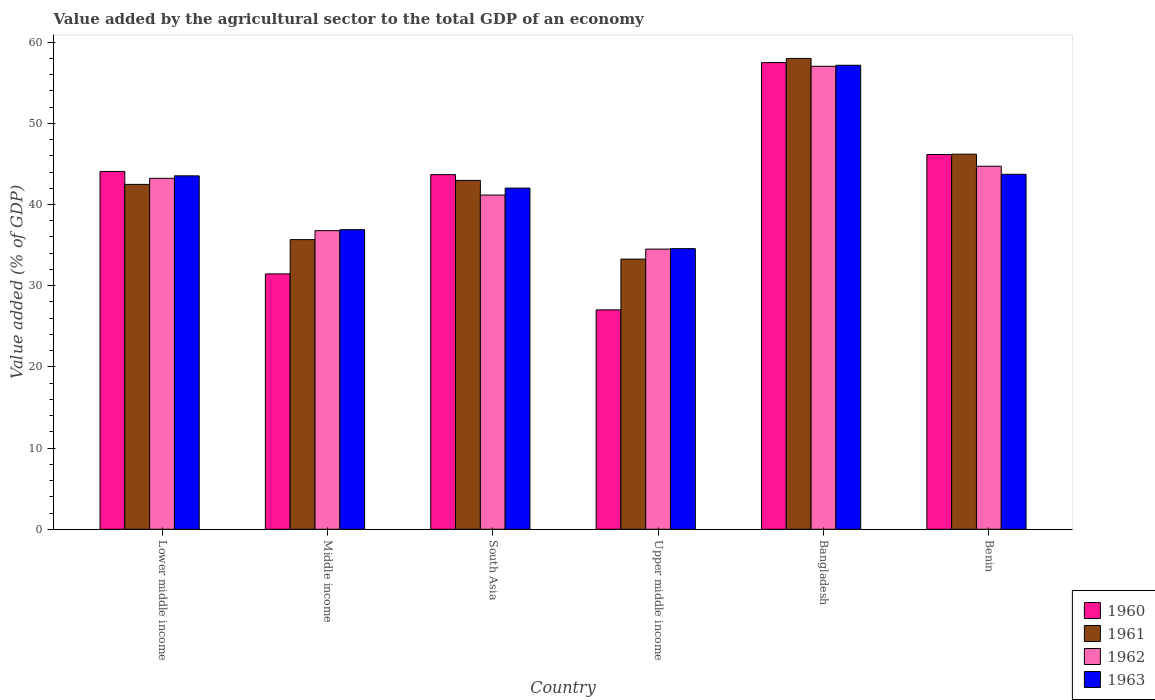How many different coloured bars are there?
Ensure brevity in your answer.  4. How many groups of bars are there?
Provide a succinct answer. 6. Are the number of bars on each tick of the X-axis equal?
Offer a terse response. Yes. How many bars are there on the 3rd tick from the left?
Make the answer very short. 4. How many bars are there on the 6th tick from the right?
Give a very brief answer. 4. What is the label of the 5th group of bars from the left?
Keep it short and to the point. Bangladesh. What is the value added by the agricultural sector to the total GDP in 1962 in South Asia?
Offer a very short reply. 41.16. Across all countries, what is the maximum value added by the agricultural sector to the total GDP in 1961?
Your answer should be compact. 57.99. Across all countries, what is the minimum value added by the agricultural sector to the total GDP in 1960?
Your answer should be very brief. 27.02. In which country was the value added by the agricultural sector to the total GDP in 1962 minimum?
Make the answer very short. Upper middle income. What is the total value added by the agricultural sector to the total GDP in 1961 in the graph?
Keep it short and to the point. 258.57. What is the difference between the value added by the agricultural sector to the total GDP in 1961 in Middle income and that in South Asia?
Offer a terse response. -7.29. What is the difference between the value added by the agricultural sector to the total GDP in 1962 in Benin and the value added by the agricultural sector to the total GDP in 1963 in Lower middle income?
Provide a short and direct response. 1.18. What is the average value added by the agricultural sector to the total GDP in 1963 per country?
Offer a terse response. 42.98. What is the difference between the value added by the agricultural sector to the total GDP of/in 1962 and value added by the agricultural sector to the total GDP of/in 1960 in Lower middle income?
Make the answer very short. -0.85. What is the ratio of the value added by the agricultural sector to the total GDP in 1960 in Lower middle income to that in Middle income?
Your answer should be very brief. 1.4. Is the value added by the agricultural sector to the total GDP in 1963 in Benin less than that in Middle income?
Your answer should be compact. No. What is the difference between the highest and the second highest value added by the agricultural sector to the total GDP in 1961?
Your answer should be compact. 15.02. What is the difference between the highest and the lowest value added by the agricultural sector to the total GDP in 1963?
Provide a succinct answer. 22.59. In how many countries, is the value added by the agricultural sector to the total GDP in 1963 greater than the average value added by the agricultural sector to the total GDP in 1963 taken over all countries?
Provide a succinct answer. 3. Is the sum of the value added by the agricultural sector to the total GDP in 1962 in Middle income and South Asia greater than the maximum value added by the agricultural sector to the total GDP in 1961 across all countries?
Keep it short and to the point. Yes. Is it the case that in every country, the sum of the value added by the agricultural sector to the total GDP in 1961 and value added by the agricultural sector to the total GDP in 1962 is greater than the value added by the agricultural sector to the total GDP in 1963?
Your answer should be very brief. Yes. Are all the bars in the graph horizontal?
Your response must be concise. No. Does the graph contain grids?
Your answer should be compact. No. How many legend labels are there?
Give a very brief answer. 4. How are the legend labels stacked?
Your response must be concise. Vertical. What is the title of the graph?
Offer a very short reply. Value added by the agricultural sector to the total GDP of an economy. Does "1968" appear as one of the legend labels in the graph?
Your response must be concise. No. What is the label or title of the Y-axis?
Your answer should be very brief. Value added (% of GDP). What is the Value added (% of GDP) of 1960 in Lower middle income?
Your answer should be compact. 44.07. What is the Value added (% of GDP) in 1961 in Lower middle income?
Keep it short and to the point. 42.48. What is the Value added (% of GDP) in 1962 in Lower middle income?
Your response must be concise. 43.22. What is the Value added (% of GDP) of 1963 in Lower middle income?
Your response must be concise. 43.53. What is the Value added (% of GDP) in 1960 in Middle income?
Your response must be concise. 31.45. What is the Value added (% of GDP) of 1961 in Middle income?
Make the answer very short. 35.67. What is the Value added (% of GDP) in 1962 in Middle income?
Offer a very short reply. 36.77. What is the Value added (% of GDP) of 1963 in Middle income?
Make the answer very short. 36.89. What is the Value added (% of GDP) in 1960 in South Asia?
Provide a short and direct response. 43.68. What is the Value added (% of GDP) of 1961 in South Asia?
Your response must be concise. 42.96. What is the Value added (% of GDP) of 1962 in South Asia?
Your answer should be very brief. 41.16. What is the Value added (% of GDP) in 1963 in South Asia?
Offer a terse response. 42.02. What is the Value added (% of GDP) of 1960 in Upper middle income?
Ensure brevity in your answer.  27.02. What is the Value added (% of GDP) in 1961 in Upper middle income?
Provide a succinct answer. 33.27. What is the Value added (% of GDP) in 1962 in Upper middle income?
Your answer should be very brief. 34.5. What is the Value added (% of GDP) in 1963 in Upper middle income?
Give a very brief answer. 34.56. What is the Value added (% of GDP) of 1960 in Bangladesh?
Give a very brief answer. 57.47. What is the Value added (% of GDP) of 1961 in Bangladesh?
Provide a succinct answer. 57.99. What is the Value added (% of GDP) in 1962 in Bangladesh?
Give a very brief answer. 57.02. What is the Value added (% of GDP) of 1963 in Bangladesh?
Offer a very short reply. 57.15. What is the Value added (% of GDP) in 1960 in Benin?
Provide a succinct answer. 46.16. What is the Value added (% of GDP) of 1961 in Benin?
Provide a short and direct response. 46.19. What is the Value added (% of GDP) in 1962 in Benin?
Ensure brevity in your answer.  44.71. What is the Value added (% of GDP) of 1963 in Benin?
Your answer should be compact. 43.72. Across all countries, what is the maximum Value added (% of GDP) of 1960?
Ensure brevity in your answer.  57.47. Across all countries, what is the maximum Value added (% of GDP) of 1961?
Offer a terse response. 57.99. Across all countries, what is the maximum Value added (% of GDP) of 1962?
Your response must be concise. 57.02. Across all countries, what is the maximum Value added (% of GDP) of 1963?
Provide a succinct answer. 57.15. Across all countries, what is the minimum Value added (% of GDP) of 1960?
Offer a terse response. 27.02. Across all countries, what is the minimum Value added (% of GDP) of 1961?
Your answer should be very brief. 33.27. Across all countries, what is the minimum Value added (% of GDP) in 1962?
Provide a succinct answer. 34.5. Across all countries, what is the minimum Value added (% of GDP) in 1963?
Your answer should be compact. 34.56. What is the total Value added (% of GDP) in 1960 in the graph?
Offer a very short reply. 249.85. What is the total Value added (% of GDP) in 1961 in the graph?
Offer a very short reply. 258.57. What is the total Value added (% of GDP) of 1962 in the graph?
Your response must be concise. 257.39. What is the total Value added (% of GDP) of 1963 in the graph?
Provide a short and direct response. 257.87. What is the difference between the Value added (% of GDP) in 1960 in Lower middle income and that in Middle income?
Offer a terse response. 12.62. What is the difference between the Value added (% of GDP) in 1961 in Lower middle income and that in Middle income?
Provide a succinct answer. 6.81. What is the difference between the Value added (% of GDP) in 1962 in Lower middle income and that in Middle income?
Offer a very short reply. 6.45. What is the difference between the Value added (% of GDP) of 1963 in Lower middle income and that in Middle income?
Your response must be concise. 6.63. What is the difference between the Value added (% of GDP) of 1960 in Lower middle income and that in South Asia?
Offer a terse response. 0.39. What is the difference between the Value added (% of GDP) in 1961 in Lower middle income and that in South Asia?
Provide a succinct answer. -0.49. What is the difference between the Value added (% of GDP) in 1962 in Lower middle income and that in South Asia?
Your response must be concise. 2.06. What is the difference between the Value added (% of GDP) of 1963 in Lower middle income and that in South Asia?
Make the answer very short. 1.51. What is the difference between the Value added (% of GDP) in 1960 in Lower middle income and that in Upper middle income?
Ensure brevity in your answer.  17.05. What is the difference between the Value added (% of GDP) of 1961 in Lower middle income and that in Upper middle income?
Your answer should be very brief. 9.2. What is the difference between the Value added (% of GDP) in 1962 in Lower middle income and that in Upper middle income?
Offer a terse response. 8.72. What is the difference between the Value added (% of GDP) of 1963 in Lower middle income and that in Upper middle income?
Your answer should be very brief. 8.97. What is the difference between the Value added (% of GDP) in 1960 in Lower middle income and that in Bangladesh?
Offer a very short reply. -13.41. What is the difference between the Value added (% of GDP) in 1961 in Lower middle income and that in Bangladesh?
Offer a very short reply. -15.51. What is the difference between the Value added (% of GDP) in 1962 in Lower middle income and that in Bangladesh?
Make the answer very short. -13.8. What is the difference between the Value added (% of GDP) in 1963 in Lower middle income and that in Bangladesh?
Provide a succinct answer. -13.62. What is the difference between the Value added (% of GDP) in 1960 in Lower middle income and that in Benin?
Provide a short and direct response. -2.09. What is the difference between the Value added (% of GDP) of 1961 in Lower middle income and that in Benin?
Provide a short and direct response. -3.72. What is the difference between the Value added (% of GDP) in 1962 in Lower middle income and that in Benin?
Keep it short and to the point. -1.49. What is the difference between the Value added (% of GDP) in 1963 in Lower middle income and that in Benin?
Provide a succinct answer. -0.19. What is the difference between the Value added (% of GDP) in 1960 in Middle income and that in South Asia?
Ensure brevity in your answer.  -12.22. What is the difference between the Value added (% of GDP) of 1961 in Middle income and that in South Asia?
Make the answer very short. -7.29. What is the difference between the Value added (% of GDP) of 1962 in Middle income and that in South Asia?
Give a very brief answer. -4.39. What is the difference between the Value added (% of GDP) of 1963 in Middle income and that in South Asia?
Your answer should be compact. -5.13. What is the difference between the Value added (% of GDP) of 1960 in Middle income and that in Upper middle income?
Give a very brief answer. 4.43. What is the difference between the Value added (% of GDP) in 1961 in Middle income and that in Upper middle income?
Your answer should be very brief. 2.4. What is the difference between the Value added (% of GDP) in 1962 in Middle income and that in Upper middle income?
Your answer should be compact. 2.27. What is the difference between the Value added (% of GDP) in 1963 in Middle income and that in Upper middle income?
Offer a terse response. 2.33. What is the difference between the Value added (% of GDP) of 1960 in Middle income and that in Bangladesh?
Offer a very short reply. -26.02. What is the difference between the Value added (% of GDP) of 1961 in Middle income and that in Bangladesh?
Give a very brief answer. -22.32. What is the difference between the Value added (% of GDP) of 1962 in Middle income and that in Bangladesh?
Your answer should be very brief. -20.24. What is the difference between the Value added (% of GDP) in 1963 in Middle income and that in Bangladesh?
Provide a short and direct response. -20.25. What is the difference between the Value added (% of GDP) in 1960 in Middle income and that in Benin?
Make the answer very short. -14.71. What is the difference between the Value added (% of GDP) in 1961 in Middle income and that in Benin?
Keep it short and to the point. -10.52. What is the difference between the Value added (% of GDP) in 1962 in Middle income and that in Benin?
Your answer should be compact. -7.94. What is the difference between the Value added (% of GDP) in 1963 in Middle income and that in Benin?
Offer a very short reply. -6.82. What is the difference between the Value added (% of GDP) in 1960 in South Asia and that in Upper middle income?
Provide a short and direct response. 16.65. What is the difference between the Value added (% of GDP) of 1961 in South Asia and that in Upper middle income?
Provide a short and direct response. 9.69. What is the difference between the Value added (% of GDP) in 1962 in South Asia and that in Upper middle income?
Your answer should be very brief. 6.66. What is the difference between the Value added (% of GDP) in 1963 in South Asia and that in Upper middle income?
Offer a terse response. 7.46. What is the difference between the Value added (% of GDP) of 1960 in South Asia and that in Bangladesh?
Keep it short and to the point. -13.8. What is the difference between the Value added (% of GDP) of 1961 in South Asia and that in Bangladesh?
Give a very brief answer. -15.02. What is the difference between the Value added (% of GDP) of 1962 in South Asia and that in Bangladesh?
Make the answer very short. -15.86. What is the difference between the Value added (% of GDP) of 1963 in South Asia and that in Bangladesh?
Your answer should be very brief. -15.13. What is the difference between the Value added (% of GDP) of 1960 in South Asia and that in Benin?
Ensure brevity in your answer.  -2.48. What is the difference between the Value added (% of GDP) in 1961 in South Asia and that in Benin?
Provide a succinct answer. -3.23. What is the difference between the Value added (% of GDP) of 1962 in South Asia and that in Benin?
Make the answer very short. -3.55. What is the difference between the Value added (% of GDP) of 1963 in South Asia and that in Benin?
Keep it short and to the point. -1.7. What is the difference between the Value added (% of GDP) of 1960 in Upper middle income and that in Bangladesh?
Your response must be concise. -30.45. What is the difference between the Value added (% of GDP) in 1961 in Upper middle income and that in Bangladesh?
Make the answer very short. -24.71. What is the difference between the Value added (% of GDP) of 1962 in Upper middle income and that in Bangladesh?
Ensure brevity in your answer.  -22.51. What is the difference between the Value added (% of GDP) in 1963 in Upper middle income and that in Bangladesh?
Provide a succinct answer. -22.59. What is the difference between the Value added (% of GDP) of 1960 in Upper middle income and that in Benin?
Provide a short and direct response. -19.14. What is the difference between the Value added (% of GDP) of 1961 in Upper middle income and that in Benin?
Make the answer very short. -12.92. What is the difference between the Value added (% of GDP) of 1962 in Upper middle income and that in Benin?
Keep it short and to the point. -10.21. What is the difference between the Value added (% of GDP) in 1963 in Upper middle income and that in Benin?
Provide a short and direct response. -9.16. What is the difference between the Value added (% of GDP) in 1960 in Bangladesh and that in Benin?
Provide a short and direct response. 11.32. What is the difference between the Value added (% of GDP) of 1961 in Bangladesh and that in Benin?
Your answer should be very brief. 11.79. What is the difference between the Value added (% of GDP) of 1962 in Bangladesh and that in Benin?
Make the answer very short. 12.31. What is the difference between the Value added (% of GDP) in 1963 in Bangladesh and that in Benin?
Offer a very short reply. 13.43. What is the difference between the Value added (% of GDP) of 1960 in Lower middle income and the Value added (% of GDP) of 1961 in Middle income?
Make the answer very short. 8.4. What is the difference between the Value added (% of GDP) of 1960 in Lower middle income and the Value added (% of GDP) of 1962 in Middle income?
Offer a very short reply. 7.29. What is the difference between the Value added (% of GDP) of 1960 in Lower middle income and the Value added (% of GDP) of 1963 in Middle income?
Provide a short and direct response. 7.17. What is the difference between the Value added (% of GDP) in 1961 in Lower middle income and the Value added (% of GDP) in 1962 in Middle income?
Make the answer very short. 5.7. What is the difference between the Value added (% of GDP) in 1961 in Lower middle income and the Value added (% of GDP) in 1963 in Middle income?
Keep it short and to the point. 5.58. What is the difference between the Value added (% of GDP) of 1962 in Lower middle income and the Value added (% of GDP) of 1963 in Middle income?
Make the answer very short. 6.33. What is the difference between the Value added (% of GDP) of 1960 in Lower middle income and the Value added (% of GDP) of 1961 in South Asia?
Offer a terse response. 1.1. What is the difference between the Value added (% of GDP) in 1960 in Lower middle income and the Value added (% of GDP) in 1962 in South Asia?
Your answer should be compact. 2.91. What is the difference between the Value added (% of GDP) of 1960 in Lower middle income and the Value added (% of GDP) of 1963 in South Asia?
Make the answer very short. 2.05. What is the difference between the Value added (% of GDP) in 1961 in Lower middle income and the Value added (% of GDP) in 1962 in South Asia?
Ensure brevity in your answer.  1.32. What is the difference between the Value added (% of GDP) of 1961 in Lower middle income and the Value added (% of GDP) of 1963 in South Asia?
Your response must be concise. 0.46. What is the difference between the Value added (% of GDP) of 1962 in Lower middle income and the Value added (% of GDP) of 1963 in South Asia?
Your answer should be very brief. 1.2. What is the difference between the Value added (% of GDP) in 1960 in Lower middle income and the Value added (% of GDP) in 1961 in Upper middle income?
Give a very brief answer. 10.79. What is the difference between the Value added (% of GDP) in 1960 in Lower middle income and the Value added (% of GDP) in 1962 in Upper middle income?
Give a very brief answer. 9.56. What is the difference between the Value added (% of GDP) in 1960 in Lower middle income and the Value added (% of GDP) in 1963 in Upper middle income?
Your response must be concise. 9.51. What is the difference between the Value added (% of GDP) of 1961 in Lower middle income and the Value added (% of GDP) of 1962 in Upper middle income?
Make the answer very short. 7.97. What is the difference between the Value added (% of GDP) in 1961 in Lower middle income and the Value added (% of GDP) in 1963 in Upper middle income?
Provide a succinct answer. 7.92. What is the difference between the Value added (% of GDP) in 1962 in Lower middle income and the Value added (% of GDP) in 1963 in Upper middle income?
Offer a terse response. 8.66. What is the difference between the Value added (% of GDP) of 1960 in Lower middle income and the Value added (% of GDP) of 1961 in Bangladesh?
Keep it short and to the point. -13.92. What is the difference between the Value added (% of GDP) in 1960 in Lower middle income and the Value added (% of GDP) in 1962 in Bangladesh?
Provide a short and direct response. -12.95. What is the difference between the Value added (% of GDP) of 1960 in Lower middle income and the Value added (% of GDP) of 1963 in Bangladesh?
Keep it short and to the point. -13.08. What is the difference between the Value added (% of GDP) in 1961 in Lower middle income and the Value added (% of GDP) in 1962 in Bangladesh?
Your response must be concise. -14.54. What is the difference between the Value added (% of GDP) in 1961 in Lower middle income and the Value added (% of GDP) in 1963 in Bangladesh?
Provide a succinct answer. -14.67. What is the difference between the Value added (% of GDP) of 1962 in Lower middle income and the Value added (% of GDP) of 1963 in Bangladesh?
Ensure brevity in your answer.  -13.93. What is the difference between the Value added (% of GDP) in 1960 in Lower middle income and the Value added (% of GDP) in 1961 in Benin?
Offer a terse response. -2.13. What is the difference between the Value added (% of GDP) in 1960 in Lower middle income and the Value added (% of GDP) in 1962 in Benin?
Offer a terse response. -0.64. What is the difference between the Value added (% of GDP) of 1960 in Lower middle income and the Value added (% of GDP) of 1963 in Benin?
Offer a very short reply. 0.35. What is the difference between the Value added (% of GDP) in 1961 in Lower middle income and the Value added (% of GDP) in 1962 in Benin?
Your response must be concise. -2.23. What is the difference between the Value added (% of GDP) in 1961 in Lower middle income and the Value added (% of GDP) in 1963 in Benin?
Make the answer very short. -1.24. What is the difference between the Value added (% of GDP) of 1962 in Lower middle income and the Value added (% of GDP) of 1963 in Benin?
Offer a terse response. -0.5. What is the difference between the Value added (% of GDP) of 1960 in Middle income and the Value added (% of GDP) of 1961 in South Asia?
Offer a very short reply. -11.51. What is the difference between the Value added (% of GDP) of 1960 in Middle income and the Value added (% of GDP) of 1962 in South Asia?
Make the answer very short. -9.71. What is the difference between the Value added (% of GDP) of 1960 in Middle income and the Value added (% of GDP) of 1963 in South Asia?
Your response must be concise. -10.57. What is the difference between the Value added (% of GDP) in 1961 in Middle income and the Value added (% of GDP) in 1962 in South Asia?
Make the answer very short. -5.49. What is the difference between the Value added (% of GDP) in 1961 in Middle income and the Value added (% of GDP) in 1963 in South Asia?
Your answer should be compact. -6.35. What is the difference between the Value added (% of GDP) in 1962 in Middle income and the Value added (% of GDP) in 1963 in South Asia?
Provide a short and direct response. -5.25. What is the difference between the Value added (% of GDP) of 1960 in Middle income and the Value added (% of GDP) of 1961 in Upper middle income?
Offer a very short reply. -1.82. What is the difference between the Value added (% of GDP) of 1960 in Middle income and the Value added (% of GDP) of 1962 in Upper middle income?
Offer a very short reply. -3.05. What is the difference between the Value added (% of GDP) in 1960 in Middle income and the Value added (% of GDP) in 1963 in Upper middle income?
Give a very brief answer. -3.11. What is the difference between the Value added (% of GDP) of 1961 in Middle income and the Value added (% of GDP) of 1962 in Upper middle income?
Provide a succinct answer. 1.17. What is the difference between the Value added (% of GDP) in 1961 in Middle income and the Value added (% of GDP) in 1963 in Upper middle income?
Provide a short and direct response. 1.11. What is the difference between the Value added (% of GDP) of 1962 in Middle income and the Value added (% of GDP) of 1963 in Upper middle income?
Provide a succinct answer. 2.21. What is the difference between the Value added (% of GDP) of 1960 in Middle income and the Value added (% of GDP) of 1961 in Bangladesh?
Ensure brevity in your answer.  -26.54. What is the difference between the Value added (% of GDP) in 1960 in Middle income and the Value added (% of GDP) in 1962 in Bangladesh?
Keep it short and to the point. -25.57. What is the difference between the Value added (% of GDP) in 1960 in Middle income and the Value added (% of GDP) in 1963 in Bangladesh?
Ensure brevity in your answer.  -25.7. What is the difference between the Value added (% of GDP) in 1961 in Middle income and the Value added (% of GDP) in 1962 in Bangladesh?
Your answer should be compact. -21.35. What is the difference between the Value added (% of GDP) of 1961 in Middle income and the Value added (% of GDP) of 1963 in Bangladesh?
Your answer should be compact. -21.48. What is the difference between the Value added (% of GDP) in 1962 in Middle income and the Value added (% of GDP) in 1963 in Bangladesh?
Provide a short and direct response. -20.37. What is the difference between the Value added (% of GDP) in 1960 in Middle income and the Value added (% of GDP) in 1961 in Benin?
Make the answer very short. -14.74. What is the difference between the Value added (% of GDP) of 1960 in Middle income and the Value added (% of GDP) of 1962 in Benin?
Offer a terse response. -13.26. What is the difference between the Value added (% of GDP) in 1960 in Middle income and the Value added (% of GDP) in 1963 in Benin?
Make the answer very short. -12.27. What is the difference between the Value added (% of GDP) in 1961 in Middle income and the Value added (% of GDP) in 1962 in Benin?
Provide a short and direct response. -9.04. What is the difference between the Value added (% of GDP) of 1961 in Middle income and the Value added (% of GDP) of 1963 in Benin?
Your response must be concise. -8.05. What is the difference between the Value added (% of GDP) of 1962 in Middle income and the Value added (% of GDP) of 1963 in Benin?
Ensure brevity in your answer.  -6.94. What is the difference between the Value added (% of GDP) of 1960 in South Asia and the Value added (% of GDP) of 1961 in Upper middle income?
Give a very brief answer. 10.4. What is the difference between the Value added (% of GDP) of 1960 in South Asia and the Value added (% of GDP) of 1962 in Upper middle income?
Provide a short and direct response. 9.17. What is the difference between the Value added (% of GDP) in 1960 in South Asia and the Value added (% of GDP) in 1963 in Upper middle income?
Ensure brevity in your answer.  9.11. What is the difference between the Value added (% of GDP) of 1961 in South Asia and the Value added (% of GDP) of 1962 in Upper middle income?
Provide a short and direct response. 8.46. What is the difference between the Value added (% of GDP) in 1961 in South Asia and the Value added (% of GDP) in 1963 in Upper middle income?
Offer a terse response. 8.4. What is the difference between the Value added (% of GDP) in 1962 in South Asia and the Value added (% of GDP) in 1963 in Upper middle income?
Provide a succinct answer. 6.6. What is the difference between the Value added (% of GDP) in 1960 in South Asia and the Value added (% of GDP) in 1961 in Bangladesh?
Offer a terse response. -14.31. What is the difference between the Value added (% of GDP) of 1960 in South Asia and the Value added (% of GDP) of 1962 in Bangladesh?
Offer a very short reply. -13.34. What is the difference between the Value added (% of GDP) of 1960 in South Asia and the Value added (% of GDP) of 1963 in Bangladesh?
Provide a succinct answer. -13.47. What is the difference between the Value added (% of GDP) in 1961 in South Asia and the Value added (% of GDP) in 1962 in Bangladesh?
Give a very brief answer. -14.05. What is the difference between the Value added (% of GDP) of 1961 in South Asia and the Value added (% of GDP) of 1963 in Bangladesh?
Your answer should be compact. -14.18. What is the difference between the Value added (% of GDP) in 1962 in South Asia and the Value added (% of GDP) in 1963 in Bangladesh?
Provide a succinct answer. -15.99. What is the difference between the Value added (% of GDP) of 1960 in South Asia and the Value added (% of GDP) of 1961 in Benin?
Make the answer very short. -2.52. What is the difference between the Value added (% of GDP) of 1960 in South Asia and the Value added (% of GDP) of 1962 in Benin?
Your answer should be compact. -1.03. What is the difference between the Value added (% of GDP) in 1960 in South Asia and the Value added (% of GDP) in 1963 in Benin?
Give a very brief answer. -0.04. What is the difference between the Value added (% of GDP) in 1961 in South Asia and the Value added (% of GDP) in 1962 in Benin?
Keep it short and to the point. -1.74. What is the difference between the Value added (% of GDP) of 1961 in South Asia and the Value added (% of GDP) of 1963 in Benin?
Make the answer very short. -0.75. What is the difference between the Value added (% of GDP) of 1962 in South Asia and the Value added (% of GDP) of 1963 in Benin?
Offer a terse response. -2.56. What is the difference between the Value added (% of GDP) of 1960 in Upper middle income and the Value added (% of GDP) of 1961 in Bangladesh?
Offer a very short reply. -30.97. What is the difference between the Value added (% of GDP) of 1960 in Upper middle income and the Value added (% of GDP) of 1962 in Bangladesh?
Provide a short and direct response. -30. What is the difference between the Value added (% of GDP) in 1960 in Upper middle income and the Value added (% of GDP) in 1963 in Bangladesh?
Keep it short and to the point. -30.12. What is the difference between the Value added (% of GDP) of 1961 in Upper middle income and the Value added (% of GDP) of 1962 in Bangladesh?
Your response must be concise. -23.74. What is the difference between the Value added (% of GDP) in 1961 in Upper middle income and the Value added (% of GDP) in 1963 in Bangladesh?
Ensure brevity in your answer.  -23.87. What is the difference between the Value added (% of GDP) of 1962 in Upper middle income and the Value added (% of GDP) of 1963 in Bangladesh?
Make the answer very short. -22.64. What is the difference between the Value added (% of GDP) in 1960 in Upper middle income and the Value added (% of GDP) in 1961 in Benin?
Your answer should be compact. -19.17. What is the difference between the Value added (% of GDP) of 1960 in Upper middle income and the Value added (% of GDP) of 1962 in Benin?
Provide a short and direct response. -17.69. What is the difference between the Value added (% of GDP) in 1960 in Upper middle income and the Value added (% of GDP) in 1963 in Benin?
Provide a succinct answer. -16.7. What is the difference between the Value added (% of GDP) of 1961 in Upper middle income and the Value added (% of GDP) of 1962 in Benin?
Your response must be concise. -11.43. What is the difference between the Value added (% of GDP) in 1961 in Upper middle income and the Value added (% of GDP) in 1963 in Benin?
Keep it short and to the point. -10.44. What is the difference between the Value added (% of GDP) in 1962 in Upper middle income and the Value added (% of GDP) in 1963 in Benin?
Provide a short and direct response. -9.21. What is the difference between the Value added (% of GDP) of 1960 in Bangladesh and the Value added (% of GDP) of 1961 in Benin?
Give a very brief answer. 11.28. What is the difference between the Value added (% of GDP) in 1960 in Bangladesh and the Value added (% of GDP) in 1962 in Benin?
Give a very brief answer. 12.77. What is the difference between the Value added (% of GDP) of 1960 in Bangladesh and the Value added (% of GDP) of 1963 in Benin?
Provide a succinct answer. 13.76. What is the difference between the Value added (% of GDP) in 1961 in Bangladesh and the Value added (% of GDP) in 1962 in Benin?
Offer a very short reply. 13.28. What is the difference between the Value added (% of GDP) of 1961 in Bangladesh and the Value added (% of GDP) of 1963 in Benin?
Provide a short and direct response. 14.27. What is the difference between the Value added (% of GDP) of 1962 in Bangladesh and the Value added (% of GDP) of 1963 in Benin?
Ensure brevity in your answer.  13.3. What is the average Value added (% of GDP) of 1960 per country?
Your response must be concise. 41.64. What is the average Value added (% of GDP) of 1961 per country?
Offer a very short reply. 43.09. What is the average Value added (% of GDP) in 1962 per country?
Offer a very short reply. 42.9. What is the average Value added (% of GDP) of 1963 per country?
Keep it short and to the point. 42.98. What is the difference between the Value added (% of GDP) of 1960 and Value added (% of GDP) of 1961 in Lower middle income?
Ensure brevity in your answer.  1.59. What is the difference between the Value added (% of GDP) of 1960 and Value added (% of GDP) of 1962 in Lower middle income?
Offer a terse response. 0.85. What is the difference between the Value added (% of GDP) of 1960 and Value added (% of GDP) of 1963 in Lower middle income?
Ensure brevity in your answer.  0.54. What is the difference between the Value added (% of GDP) in 1961 and Value added (% of GDP) in 1962 in Lower middle income?
Your response must be concise. -0.75. What is the difference between the Value added (% of GDP) in 1961 and Value added (% of GDP) in 1963 in Lower middle income?
Provide a short and direct response. -1.05. What is the difference between the Value added (% of GDP) in 1962 and Value added (% of GDP) in 1963 in Lower middle income?
Provide a succinct answer. -0.3. What is the difference between the Value added (% of GDP) of 1960 and Value added (% of GDP) of 1961 in Middle income?
Ensure brevity in your answer.  -4.22. What is the difference between the Value added (% of GDP) of 1960 and Value added (% of GDP) of 1962 in Middle income?
Your answer should be compact. -5.32. What is the difference between the Value added (% of GDP) of 1960 and Value added (% of GDP) of 1963 in Middle income?
Provide a short and direct response. -5.44. What is the difference between the Value added (% of GDP) in 1961 and Value added (% of GDP) in 1962 in Middle income?
Your response must be concise. -1.1. What is the difference between the Value added (% of GDP) of 1961 and Value added (% of GDP) of 1963 in Middle income?
Ensure brevity in your answer.  -1.22. What is the difference between the Value added (% of GDP) in 1962 and Value added (% of GDP) in 1963 in Middle income?
Your response must be concise. -0.12. What is the difference between the Value added (% of GDP) in 1960 and Value added (% of GDP) in 1961 in South Asia?
Offer a very short reply. 0.71. What is the difference between the Value added (% of GDP) in 1960 and Value added (% of GDP) in 1962 in South Asia?
Your answer should be compact. 2.52. What is the difference between the Value added (% of GDP) of 1960 and Value added (% of GDP) of 1963 in South Asia?
Give a very brief answer. 1.66. What is the difference between the Value added (% of GDP) of 1961 and Value added (% of GDP) of 1962 in South Asia?
Offer a terse response. 1.8. What is the difference between the Value added (% of GDP) of 1961 and Value added (% of GDP) of 1963 in South Asia?
Provide a succinct answer. 0.95. What is the difference between the Value added (% of GDP) in 1962 and Value added (% of GDP) in 1963 in South Asia?
Make the answer very short. -0.86. What is the difference between the Value added (% of GDP) of 1960 and Value added (% of GDP) of 1961 in Upper middle income?
Make the answer very short. -6.25. What is the difference between the Value added (% of GDP) in 1960 and Value added (% of GDP) in 1962 in Upper middle income?
Keep it short and to the point. -7.48. What is the difference between the Value added (% of GDP) of 1960 and Value added (% of GDP) of 1963 in Upper middle income?
Your answer should be compact. -7.54. What is the difference between the Value added (% of GDP) in 1961 and Value added (% of GDP) in 1962 in Upper middle income?
Offer a terse response. -1.23. What is the difference between the Value added (% of GDP) in 1961 and Value added (% of GDP) in 1963 in Upper middle income?
Your answer should be compact. -1.29. What is the difference between the Value added (% of GDP) of 1962 and Value added (% of GDP) of 1963 in Upper middle income?
Keep it short and to the point. -0.06. What is the difference between the Value added (% of GDP) of 1960 and Value added (% of GDP) of 1961 in Bangladesh?
Your response must be concise. -0.51. What is the difference between the Value added (% of GDP) of 1960 and Value added (% of GDP) of 1962 in Bangladesh?
Offer a very short reply. 0.46. What is the difference between the Value added (% of GDP) of 1960 and Value added (% of GDP) of 1963 in Bangladesh?
Provide a succinct answer. 0.33. What is the difference between the Value added (% of GDP) of 1961 and Value added (% of GDP) of 1962 in Bangladesh?
Give a very brief answer. 0.97. What is the difference between the Value added (% of GDP) of 1961 and Value added (% of GDP) of 1963 in Bangladesh?
Provide a short and direct response. 0.84. What is the difference between the Value added (% of GDP) of 1962 and Value added (% of GDP) of 1963 in Bangladesh?
Your answer should be very brief. -0.13. What is the difference between the Value added (% of GDP) of 1960 and Value added (% of GDP) of 1961 in Benin?
Offer a terse response. -0.04. What is the difference between the Value added (% of GDP) in 1960 and Value added (% of GDP) in 1962 in Benin?
Your response must be concise. 1.45. What is the difference between the Value added (% of GDP) in 1960 and Value added (% of GDP) in 1963 in Benin?
Give a very brief answer. 2.44. What is the difference between the Value added (% of GDP) in 1961 and Value added (% of GDP) in 1962 in Benin?
Give a very brief answer. 1.48. What is the difference between the Value added (% of GDP) in 1961 and Value added (% of GDP) in 1963 in Benin?
Your answer should be compact. 2.48. What is the difference between the Value added (% of GDP) in 1962 and Value added (% of GDP) in 1963 in Benin?
Ensure brevity in your answer.  0.99. What is the ratio of the Value added (% of GDP) in 1960 in Lower middle income to that in Middle income?
Provide a short and direct response. 1.4. What is the ratio of the Value added (% of GDP) of 1961 in Lower middle income to that in Middle income?
Provide a short and direct response. 1.19. What is the ratio of the Value added (% of GDP) of 1962 in Lower middle income to that in Middle income?
Offer a terse response. 1.18. What is the ratio of the Value added (% of GDP) of 1963 in Lower middle income to that in Middle income?
Your answer should be very brief. 1.18. What is the ratio of the Value added (% of GDP) of 1960 in Lower middle income to that in South Asia?
Ensure brevity in your answer.  1.01. What is the ratio of the Value added (% of GDP) of 1962 in Lower middle income to that in South Asia?
Offer a terse response. 1.05. What is the ratio of the Value added (% of GDP) in 1963 in Lower middle income to that in South Asia?
Keep it short and to the point. 1.04. What is the ratio of the Value added (% of GDP) of 1960 in Lower middle income to that in Upper middle income?
Your answer should be very brief. 1.63. What is the ratio of the Value added (% of GDP) of 1961 in Lower middle income to that in Upper middle income?
Keep it short and to the point. 1.28. What is the ratio of the Value added (% of GDP) of 1962 in Lower middle income to that in Upper middle income?
Offer a terse response. 1.25. What is the ratio of the Value added (% of GDP) in 1963 in Lower middle income to that in Upper middle income?
Offer a very short reply. 1.26. What is the ratio of the Value added (% of GDP) of 1960 in Lower middle income to that in Bangladesh?
Your response must be concise. 0.77. What is the ratio of the Value added (% of GDP) of 1961 in Lower middle income to that in Bangladesh?
Offer a terse response. 0.73. What is the ratio of the Value added (% of GDP) of 1962 in Lower middle income to that in Bangladesh?
Keep it short and to the point. 0.76. What is the ratio of the Value added (% of GDP) of 1963 in Lower middle income to that in Bangladesh?
Offer a very short reply. 0.76. What is the ratio of the Value added (% of GDP) of 1960 in Lower middle income to that in Benin?
Offer a very short reply. 0.95. What is the ratio of the Value added (% of GDP) of 1961 in Lower middle income to that in Benin?
Give a very brief answer. 0.92. What is the ratio of the Value added (% of GDP) in 1962 in Lower middle income to that in Benin?
Give a very brief answer. 0.97. What is the ratio of the Value added (% of GDP) in 1963 in Lower middle income to that in Benin?
Make the answer very short. 1. What is the ratio of the Value added (% of GDP) in 1960 in Middle income to that in South Asia?
Provide a succinct answer. 0.72. What is the ratio of the Value added (% of GDP) of 1961 in Middle income to that in South Asia?
Your response must be concise. 0.83. What is the ratio of the Value added (% of GDP) in 1962 in Middle income to that in South Asia?
Your answer should be compact. 0.89. What is the ratio of the Value added (% of GDP) in 1963 in Middle income to that in South Asia?
Provide a short and direct response. 0.88. What is the ratio of the Value added (% of GDP) in 1960 in Middle income to that in Upper middle income?
Keep it short and to the point. 1.16. What is the ratio of the Value added (% of GDP) in 1961 in Middle income to that in Upper middle income?
Keep it short and to the point. 1.07. What is the ratio of the Value added (% of GDP) of 1962 in Middle income to that in Upper middle income?
Provide a succinct answer. 1.07. What is the ratio of the Value added (% of GDP) of 1963 in Middle income to that in Upper middle income?
Provide a short and direct response. 1.07. What is the ratio of the Value added (% of GDP) of 1960 in Middle income to that in Bangladesh?
Provide a short and direct response. 0.55. What is the ratio of the Value added (% of GDP) of 1961 in Middle income to that in Bangladesh?
Provide a succinct answer. 0.62. What is the ratio of the Value added (% of GDP) of 1962 in Middle income to that in Bangladesh?
Give a very brief answer. 0.64. What is the ratio of the Value added (% of GDP) in 1963 in Middle income to that in Bangladesh?
Give a very brief answer. 0.65. What is the ratio of the Value added (% of GDP) of 1960 in Middle income to that in Benin?
Keep it short and to the point. 0.68. What is the ratio of the Value added (% of GDP) of 1961 in Middle income to that in Benin?
Offer a terse response. 0.77. What is the ratio of the Value added (% of GDP) of 1962 in Middle income to that in Benin?
Ensure brevity in your answer.  0.82. What is the ratio of the Value added (% of GDP) of 1963 in Middle income to that in Benin?
Your response must be concise. 0.84. What is the ratio of the Value added (% of GDP) of 1960 in South Asia to that in Upper middle income?
Ensure brevity in your answer.  1.62. What is the ratio of the Value added (% of GDP) in 1961 in South Asia to that in Upper middle income?
Provide a succinct answer. 1.29. What is the ratio of the Value added (% of GDP) of 1962 in South Asia to that in Upper middle income?
Keep it short and to the point. 1.19. What is the ratio of the Value added (% of GDP) in 1963 in South Asia to that in Upper middle income?
Ensure brevity in your answer.  1.22. What is the ratio of the Value added (% of GDP) of 1960 in South Asia to that in Bangladesh?
Make the answer very short. 0.76. What is the ratio of the Value added (% of GDP) of 1961 in South Asia to that in Bangladesh?
Your answer should be compact. 0.74. What is the ratio of the Value added (% of GDP) in 1962 in South Asia to that in Bangladesh?
Offer a terse response. 0.72. What is the ratio of the Value added (% of GDP) in 1963 in South Asia to that in Bangladesh?
Provide a short and direct response. 0.74. What is the ratio of the Value added (% of GDP) of 1960 in South Asia to that in Benin?
Offer a very short reply. 0.95. What is the ratio of the Value added (% of GDP) of 1961 in South Asia to that in Benin?
Give a very brief answer. 0.93. What is the ratio of the Value added (% of GDP) of 1962 in South Asia to that in Benin?
Ensure brevity in your answer.  0.92. What is the ratio of the Value added (% of GDP) of 1963 in South Asia to that in Benin?
Your answer should be compact. 0.96. What is the ratio of the Value added (% of GDP) in 1960 in Upper middle income to that in Bangladesh?
Your response must be concise. 0.47. What is the ratio of the Value added (% of GDP) in 1961 in Upper middle income to that in Bangladesh?
Your response must be concise. 0.57. What is the ratio of the Value added (% of GDP) of 1962 in Upper middle income to that in Bangladesh?
Provide a short and direct response. 0.61. What is the ratio of the Value added (% of GDP) in 1963 in Upper middle income to that in Bangladesh?
Make the answer very short. 0.6. What is the ratio of the Value added (% of GDP) of 1960 in Upper middle income to that in Benin?
Provide a succinct answer. 0.59. What is the ratio of the Value added (% of GDP) in 1961 in Upper middle income to that in Benin?
Give a very brief answer. 0.72. What is the ratio of the Value added (% of GDP) in 1962 in Upper middle income to that in Benin?
Provide a short and direct response. 0.77. What is the ratio of the Value added (% of GDP) in 1963 in Upper middle income to that in Benin?
Your response must be concise. 0.79. What is the ratio of the Value added (% of GDP) of 1960 in Bangladesh to that in Benin?
Your response must be concise. 1.25. What is the ratio of the Value added (% of GDP) in 1961 in Bangladesh to that in Benin?
Give a very brief answer. 1.26. What is the ratio of the Value added (% of GDP) of 1962 in Bangladesh to that in Benin?
Keep it short and to the point. 1.28. What is the ratio of the Value added (% of GDP) in 1963 in Bangladesh to that in Benin?
Your answer should be very brief. 1.31. What is the difference between the highest and the second highest Value added (% of GDP) in 1960?
Give a very brief answer. 11.32. What is the difference between the highest and the second highest Value added (% of GDP) in 1961?
Your answer should be very brief. 11.79. What is the difference between the highest and the second highest Value added (% of GDP) of 1962?
Make the answer very short. 12.31. What is the difference between the highest and the second highest Value added (% of GDP) of 1963?
Ensure brevity in your answer.  13.43. What is the difference between the highest and the lowest Value added (% of GDP) in 1960?
Give a very brief answer. 30.45. What is the difference between the highest and the lowest Value added (% of GDP) in 1961?
Keep it short and to the point. 24.71. What is the difference between the highest and the lowest Value added (% of GDP) in 1962?
Ensure brevity in your answer.  22.51. What is the difference between the highest and the lowest Value added (% of GDP) of 1963?
Provide a short and direct response. 22.59. 